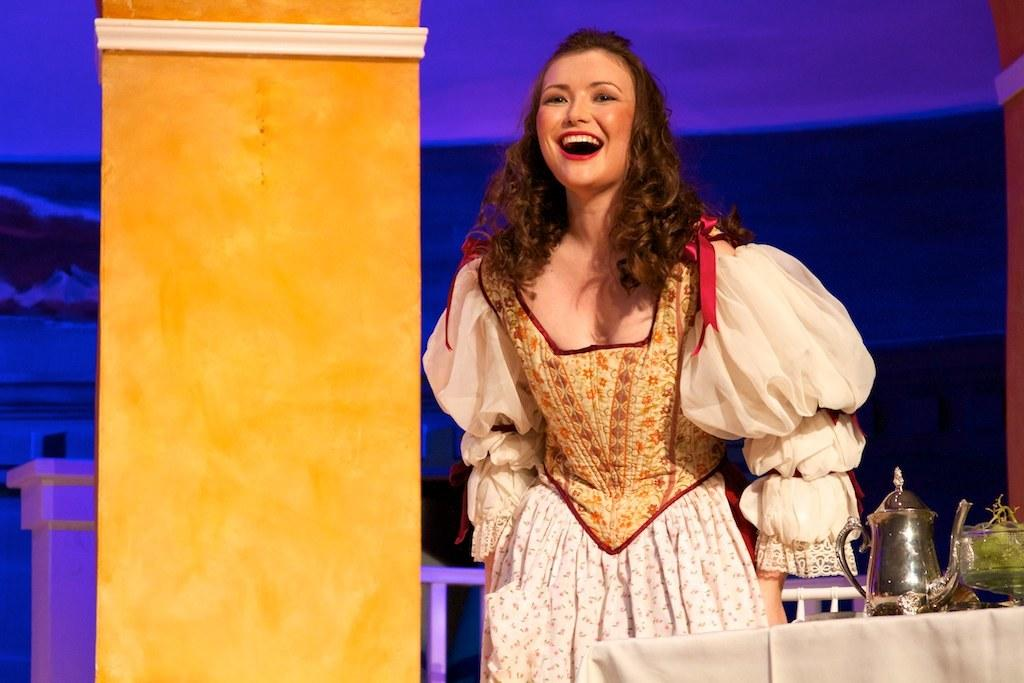Who is present in the image? There is a woman in the image. What is the woman doing in the image? The woman is standing and smiling. What objects can be seen in the image besides the woman? There is a kettle, a white cloth, and a bowl in the image. Where is the bowl located in the image? The bowl is on the right side. What is visible in the background of the image? There are pillars in the background of the image. What type of base can be seen supporting the basket in the image? There is no basket or base present in the image. 